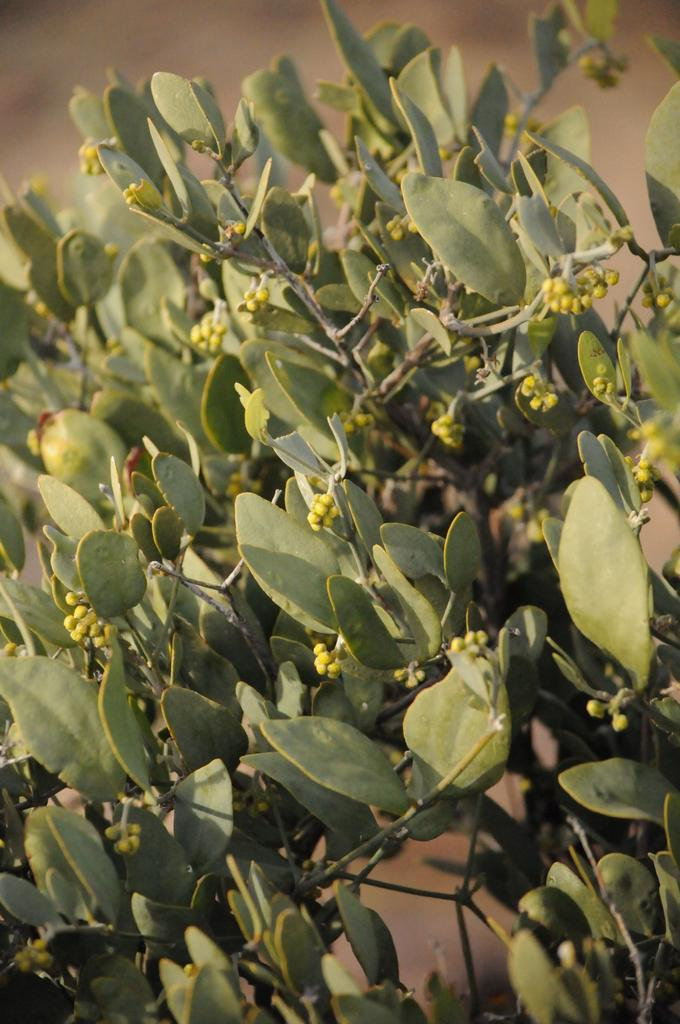What type of living organisms can be seen in the image? Plants can be seen in the image. Can you describe the background of the image? The background of the image is blurred. What type of science experiment is being conducted in the image? There is no indication of a science experiment or any scientific activity in the image. 